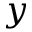<formula> <loc_0><loc_0><loc_500><loc_500>y</formula> 